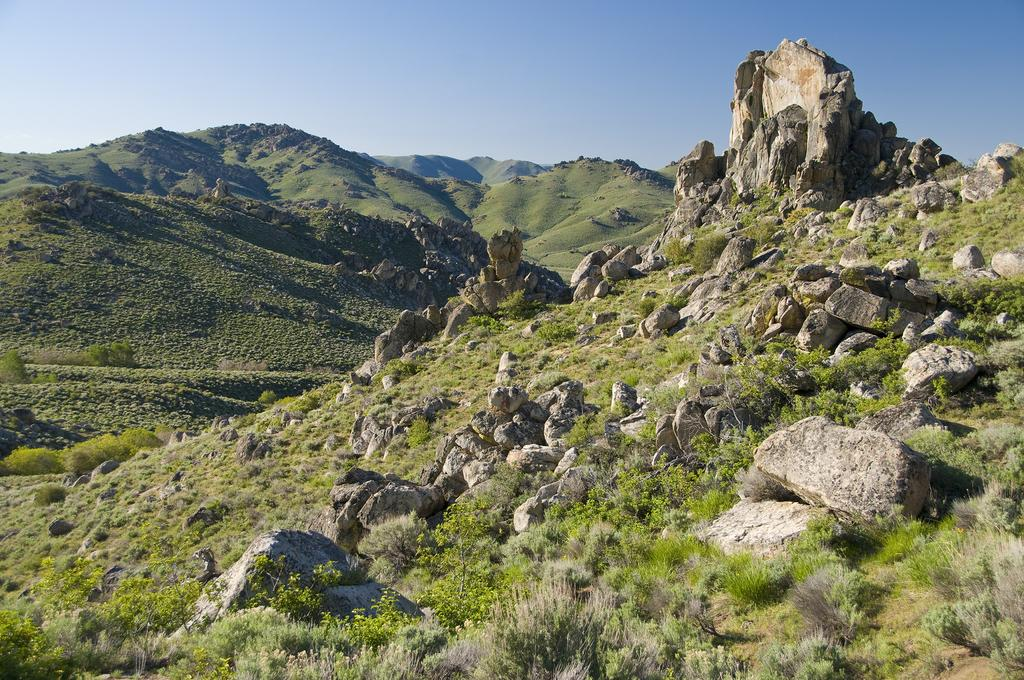What type of natural landscape can be seen in the image? There are hills in the image. What other elements can be found in the landscape? Rocks, plants, and grass are visible in the image. What is visible at the top of the image? The sky is visible at the top of the image. What type of cabbage can be seen growing on the square in the image? There is no cabbage or square present in the image; it features a natural landscape with hills, rocks, plants, grass, and the sky. 